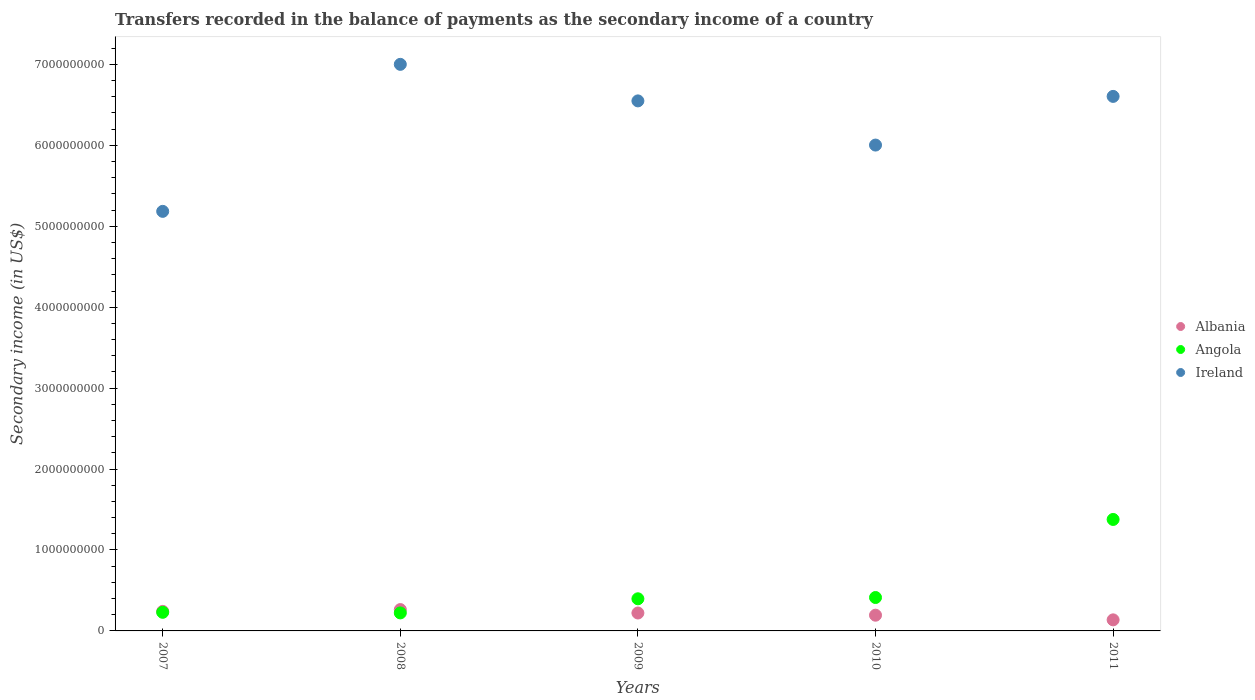Is the number of dotlines equal to the number of legend labels?
Provide a succinct answer. Yes. What is the secondary income of in Albania in 2007?
Your answer should be compact. 2.41e+08. Across all years, what is the maximum secondary income of in Angola?
Provide a succinct answer. 1.38e+09. Across all years, what is the minimum secondary income of in Albania?
Provide a succinct answer. 1.37e+08. In which year was the secondary income of in Angola maximum?
Offer a terse response. 2011. What is the total secondary income of in Angola in the graph?
Give a very brief answer. 2.64e+09. What is the difference between the secondary income of in Ireland in 2009 and that in 2010?
Make the answer very short. 5.46e+08. What is the difference between the secondary income of in Albania in 2009 and the secondary income of in Ireland in 2007?
Ensure brevity in your answer.  -4.96e+09. What is the average secondary income of in Albania per year?
Provide a short and direct response. 2.12e+08. In the year 2007, what is the difference between the secondary income of in Ireland and secondary income of in Albania?
Your answer should be very brief. 4.94e+09. In how many years, is the secondary income of in Angola greater than 3200000000 US$?
Provide a succinct answer. 0. What is the ratio of the secondary income of in Albania in 2008 to that in 2010?
Your answer should be compact. 1.36. What is the difference between the highest and the second highest secondary income of in Ireland?
Ensure brevity in your answer.  3.96e+08. What is the difference between the highest and the lowest secondary income of in Angola?
Your answer should be very brief. 1.15e+09. In how many years, is the secondary income of in Angola greater than the average secondary income of in Angola taken over all years?
Offer a very short reply. 1. Is the sum of the secondary income of in Albania in 2007 and 2010 greater than the maximum secondary income of in Angola across all years?
Offer a very short reply. No. Is it the case that in every year, the sum of the secondary income of in Albania and secondary income of in Ireland  is greater than the secondary income of in Angola?
Make the answer very short. Yes. Does the secondary income of in Angola monotonically increase over the years?
Make the answer very short. No. Is the secondary income of in Ireland strictly less than the secondary income of in Angola over the years?
Your answer should be compact. No. How many years are there in the graph?
Provide a succinct answer. 5. What is the difference between two consecutive major ticks on the Y-axis?
Your answer should be very brief. 1.00e+09. Are the values on the major ticks of Y-axis written in scientific E-notation?
Offer a very short reply. No. Does the graph contain grids?
Your response must be concise. No. What is the title of the graph?
Give a very brief answer. Transfers recorded in the balance of payments as the secondary income of a country. Does "Netherlands" appear as one of the legend labels in the graph?
Your answer should be compact. No. What is the label or title of the Y-axis?
Give a very brief answer. Secondary income (in US$). What is the Secondary income (in US$) of Albania in 2007?
Give a very brief answer. 2.41e+08. What is the Secondary income (in US$) of Angola in 2007?
Provide a short and direct response. 2.30e+08. What is the Secondary income (in US$) in Ireland in 2007?
Your response must be concise. 5.18e+09. What is the Secondary income (in US$) in Albania in 2008?
Your answer should be compact. 2.64e+08. What is the Secondary income (in US$) of Angola in 2008?
Your answer should be compact. 2.22e+08. What is the Secondary income (in US$) in Ireland in 2008?
Your answer should be very brief. 7.00e+09. What is the Secondary income (in US$) in Albania in 2009?
Provide a short and direct response. 2.21e+08. What is the Secondary income (in US$) of Angola in 2009?
Offer a terse response. 3.97e+08. What is the Secondary income (in US$) in Ireland in 2009?
Your response must be concise. 6.55e+09. What is the Secondary income (in US$) of Albania in 2010?
Give a very brief answer. 1.94e+08. What is the Secondary income (in US$) of Angola in 2010?
Provide a succinct answer. 4.13e+08. What is the Secondary income (in US$) in Ireland in 2010?
Provide a short and direct response. 6.00e+09. What is the Secondary income (in US$) of Albania in 2011?
Provide a short and direct response. 1.37e+08. What is the Secondary income (in US$) of Angola in 2011?
Give a very brief answer. 1.38e+09. What is the Secondary income (in US$) in Ireland in 2011?
Make the answer very short. 6.61e+09. Across all years, what is the maximum Secondary income (in US$) of Albania?
Your response must be concise. 2.64e+08. Across all years, what is the maximum Secondary income (in US$) of Angola?
Your answer should be compact. 1.38e+09. Across all years, what is the maximum Secondary income (in US$) of Ireland?
Give a very brief answer. 7.00e+09. Across all years, what is the minimum Secondary income (in US$) of Albania?
Offer a very short reply. 1.37e+08. Across all years, what is the minimum Secondary income (in US$) in Angola?
Your response must be concise. 2.22e+08. Across all years, what is the minimum Secondary income (in US$) of Ireland?
Offer a terse response. 5.18e+09. What is the total Secondary income (in US$) in Albania in the graph?
Provide a short and direct response. 1.06e+09. What is the total Secondary income (in US$) in Angola in the graph?
Ensure brevity in your answer.  2.64e+09. What is the total Secondary income (in US$) in Ireland in the graph?
Give a very brief answer. 3.13e+1. What is the difference between the Secondary income (in US$) of Albania in 2007 and that in 2008?
Provide a short and direct response. -2.24e+07. What is the difference between the Secondary income (in US$) of Angola in 2007 and that in 2008?
Your response must be concise. 7.45e+06. What is the difference between the Secondary income (in US$) of Ireland in 2007 and that in 2008?
Offer a terse response. -1.82e+09. What is the difference between the Secondary income (in US$) in Albania in 2007 and that in 2009?
Keep it short and to the point. 2.00e+07. What is the difference between the Secondary income (in US$) of Angola in 2007 and that in 2009?
Offer a terse response. -1.67e+08. What is the difference between the Secondary income (in US$) of Ireland in 2007 and that in 2009?
Keep it short and to the point. -1.37e+09. What is the difference between the Secondary income (in US$) of Albania in 2007 and that in 2010?
Make the answer very short. 4.71e+07. What is the difference between the Secondary income (in US$) of Angola in 2007 and that in 2010?
Make the answer very short. -1.83e+08. What is the difference between the Secondary income (in US$) of Ireland in 2007 and that in 2010?
Give a very brief answer. -8.19e+08. What is the difference between the Secondary income (in US$) in Albania in 2007 and that in 2011?
Ensure brevity in your answer.  1.05e+08. What is the difference between the Secondary income (in US$) in Angola in 2007 and that in 2011?
Make the answer very short. -1.15e+09. What is the difference between the Secondary income (in US$) of Ireland in 2007 and that in 2011?
Give a very brief answer. -1.42e+09. What is the difference between the Secondary income (in US$) in Albania in 2008 and that in 2009?
Make the answer very short. 4.23e+07. What is the difference between the Secondary income (in US$) of Angola in 2008 and that in 2009?
Offer a terse response. -1.75e+08. What is the difference between the Secondary income (in US$) in Ireland in 2008 and that in 2009?
Offer a terse response. 4.52e+08. What is the difference between the Secondary income (in US$) in Albania in 2008 and that in 2010?
Make the answer very short. 6.94e+07. What is the difference between the Secondary income (in US$) in Angola in 2008 and that in 2010?
Ensure brevity in your answer.  -1.90e+08. What is the difference between the Secondary income (in US$) of Ireland in 2008 and that in 2010?
Your answer should be compact. 9.97e+08. What is the difference between the Secondary income (in US$) in Albania in 2008 and that in 2011?
Make the answer very short. 1.27e+08. What is the difference between the Secondary income (in US$) of Angola in 2008 and that in 2011?
Your answer should be very brief. -1.15e+09. What is the difference between the Secondary income (in US$) in Ireland in 2008 and that in 2011?
Your answer should be compact. 3.96e+08. What is the difference between the Secondary income (in US$) of Albania in 2009 and that in 2010?
Your answer should be compact. 2.71e+07. What is the difference between the Secondary income (in US$) of Angola in 2009 and that in 2010?
Provide a short and direct response. -1.57e+07. What is the difference between the Secondary income (in US$) of Ireland in 2009 and that in 2010?
Ensure brevity in your answer.  5.46e+08. What is the difference between the Secondary income (in US$) in Albania in 2009 and that in 2011?
Provide a succinct answer. 8.47e+07. What is the difference between the Secondary income (in US$) of Angola in 2009 and that in 2011?
Give a very brief answer. -9.80e+08. What is the difference between the Secondary income (in US$) of Ireland in 2009 and that in 2011?
Your answer should be compact. -5.56e+07. What is the difference between the Secondary income (in US$) in Albania in 2010 and that in 2011?
Offer a very short reply. 5.76e+07. What is the difference between the Secondary income (in US$) in Angola in 2010 and that in 2011?
Offer a very short reply. -9.65e+08. What is the difference between the Secondary income (in US$) in Ireland in 2010 and that in 2011?
Make the answer very short. -6.02e+08. What is the difference between the Secondary income (in US$) of Albania in 2007 and the Secondary income (in US$) of Angola in 2008?
Provide a succinct answer. 1.89e+07. What is the difference between the Secondary income (in US$) of Albania in 2007 and the Secondary income (in US$) of Ireland in 2008?
Offer a terse response. -6.76e+09. What is the difference between the Secondary income (in US$) in Angola in 2007 and the Secondary income (in US$) in Ireland in 2008?
Offer a terse response. -6.77e+09. What is the difference between the Secondary income (in US$) of Albania in 2007 and the Secondary income (in US$) of Angola in 2009?
Your answer should be very brief. -1.56e+08. What is the difference between the Secondary income (in US$) of Albania in 2007 and the Secondary income (in US$) of Ireland in 2009?
Make the answer very short. -6.31e+09. What is the difference between the Secondary income (in US$) of Angola in 2007 and the Secondary income (in US$) of Ireland in 2009?
Offer a terse response. -6.32e+09. What is the difference between the Secondary income (in US$) in Albania in 2007 and the Secondary income (in US$) in Angola in 2010?
Keep it short and to the point. -1.71e+08. What is the difference between the Secondary income (in US$) of Albania in 2007 and the Secondary income (in US$) of Ireland in 2010?
Offer a terse response. -5.76e+09. What is the difference between the Secondary income (in US$) in Angola in 2007 and the Secondary income (in US$) in Ireland in 2010?
Your answer should be compact. -5.77e+09. What is the difference between the Secondary income (in US$) of Albania in 2007 and the Secondary income (in US$) of Angola in 2011?
Offer a terse response. -1.14e+09. What is the difference between the Secondary income (in US$) in Albania in 2007 and the Secondary income (in US$) in Ireland in 2011?
Make the answer very short. -6.36e+09. What is the difference between the Secondary income (in US$) in Angola in 2007 and the Secondary income (in US$) in Ireland in 2011?
Your answer should be very brief. -6.38e+09. What is the difference between the Secondary income (in US$) in Albania in 2008 and the Secondary income (in US$) in Angola in 2009?
Provide a succinct answer. -1.33e+08. What is the difference between the Secondary income (in US$) of Albania in 2008 and the Secondary income (in US$) of Ireland in 2009?
Offer a very short reply. -6.29e+09. What is the difference between the Secondary income (in US$) of Angola in 2008 and the Secondary income (in US$) of Ireland in 2009?
Your response must be concise. -6.33e+09. What is the difference between the Secondary income (in US$) of Albania in 2008 and the Secondary income (in US$) of Angola in 2010?
Your response must be concise. -1.49e+08. What is the difference between the Secondary income (in US$) of Albania in 2008 and the Secondary income (in US$) of Ireland in 2010?
Your answer should be compact. -5.74e+09. What is the difference between the Secondary income (in US$) in Angola in 2008 and the Secondary income (in US$) in Ireland in 2010?
Your answer should be very brief. -5.78e+09. What is the difference between the Secondary income (in US$) of Albania in 2008 and the Secondary income (in US$) of Angola in 2011?
Your response must be concise. -1.11e+09. What is the difference between the Secondary income (in US$) of Albania in 2008 and the Secondary income (in US$) of Ireland in 2011?
Ensure brevity in your answer.  -6.34e+09. What is the difference between the Secondary income (in US$) in Angola in 2008 and the Secondary income (in US$) in Ireland in 2011?
Give a very brief answer. -6.38e+09. What is the difference between the Secondary income (in US$) of Albania in 2009 and the Secondary income (in US$) of Angola in 2010?
Make the answer very short. -1.91e+08. What is the difference between the Secondary income (in US$) in Albania in 2009 and the Secondary income (in US$) in Ireland in 2010?
Ensure brevity in your answer.  -5.78e+09. What is the difference between the Secondary income (in US$) of Angola in 2009 and the Secondary income (in US$) of Ireland in 2010?
Your answer should be compact. -5.61e+09. What is the difference between the Secondary income (in US$) in Albania in 2009 and the Secondary income (in US$) in Angola in 2011?
Give a very brief answer. -1.16e+09. What is the difference between the Secondary income (in US$) in Albania in 2009 and the Secondary income (in US$) in Ireland in 2011?
Give a very brief answer. -6.38e+09. What is the difference between the Secondary income (in US$) of Angola in 2009 and the Secondary income (in US$) of Ireland in 2011?
Offer a terse response. -6.21e+09. What is the difference between the Secondary income (in US$) in Albania in 2010 and the Secondary income (in US$) in Angola in 2011?
Provide a short and direct response. -1.18e+09. What is the difference between the Secondary income (in US$) of Albania in 2010 and the Secondary income (in US$) of Ireland in 2011?
Make the answer very short. -6.41e+09. What is the difference between the Secondary income (in US$) of Angola in 2010 and the Secondary income (in US$) of Ireland in 2011?
Provide a succinct answer. -6.19e+09. What is the average Secondary income (in US$) in Albania per year?
Offer a terse response. 2.12e+08. What is the average Secondary income (in US$) of Angola per year?
Your answer should be compact. 5.28e+08. What is the average Secondary income (in US$) of Ireland per year?
Offer a very short reply. 6.27e+09. In the year 2007, what is the difference between the Secondary income (in US$) in Albania and Secondary income (in US$) in Angola?
Your answer should be very brief. 1.15e+07. In the year 2007, what is the difference between the Secondary income (in US$) of Albania and Secondary income (in US$) of Ireland?
Ensure brevity in your answer.  -4.94e+09. In the year 2007, what is the difference between the Secondary income (in US$) of Angola and Secondary income (in US$) of Ireland?
Ensure brevity in your answer.  -4.95e+09. In the year 2008, what is the difference between the Secondary income (in US$) of Albania and Secondary income (in US$) of Angola?
Offer a terse response. 4.13e+07. In the year 2008, what is the difference between the Secondary income (in US$) in Albania and Secondary income (in US$) in Ireland?
Make the answer very short. -6.74e+09. In the year 2008, what is the difference between the Secondary income (in US$) of Angola and Secondary income (in US$) of Ireland?
Your answer should be compact. -6.78e+09. In the year 2009, what is the difference between the Secondary income (in US$) of Albania and Secondary income (in US$) of Angola?
Offer a very short reply. -1.76e+08. In the year 2009, what is the difference between the Secondary income (in US$) of Albania and Secondary income (in US$) of Ireland?
Keep it short and to the point. -6.33e+09. In the year 2009, what is the difference between the Secondary income (in US$) in Angola and Secondary income (in US$) in Ireland?
Provide a succinct answer. -6.15e+09. In the year 2010, what is the difference between the Secondary income (in US$) of Albania and Secondary income (in US$) of Angola?
Your response must be concise. -2.18e+08. In the year 2010, what is the difference between the Secondary income (in US$) in Albania and Secondary income (in US$) in Ireland?
Your answer should be compact. -5.81e+09. In the year 2010, what is the difference between the Secondary income (in US$) of Angola and Secondary income (in US$) of Ireland?
Your answer should be compact. -5.59e+09. In the year 2011, what is the difference between the Secondary income (in US$) in Albania and Secondary income (in US$) in Angola?
Offer a very short reply. -1.24e+09. In the year 2011, what is the difference between the Secondary income (in US$) in Albania and Secondary income (in US$) in Ireland?
Your answer should be very brief. -6.47e+09. In the year 2011, what is the difference between the Secondary income (in US$) in Angola and Secondary income (in US$) in Ireland?
Offer a very short reply. -5.23e+09. What is the ratio of the Secondary income (in US$) in Albania in 2007 to that in 2008?
Give a very brief answer. 0.92. What is the ratio of the Secondary income (in US$) of Angola in 2007 to that in 2008?
Ensure brevity in your answer.  1.03. What is the ratio of the Secondary income (in US$) in Ireland in 2007 to that in 2008?
Offer a terse response. 0.74. What is the ratio of the Secondary income (in US$) in Albania in 2007 to that in 2009?
Offer a very short reply. 1.09. What is the ratio of the Secondary income (in US$) in Angola in 2007 to that in 2009?
Offer a very short reply. 0.58. What is the ratio of the Secondary income (in US$) in Ireland in 2007 to that in 2009?
Offer a terse response. 0.79. What is the ratio of the Secondary income (in US$) in Albania in 2007 to that in 2010?
Your answer should be compact. 1.24. What is the ratio of the Secondary income (in US$) of Angola in 2007 to that in 2010?
Provide a succinct answer. 0.56. What is the ratio of the Secondary income (in US$) in Ireland in 2007 to that in 2010?
Ensure brevity in your answer.  0.86. What is the ratio of the Secondary income (in US$) in Albania in 2007 to that in 2011?
Offer a terse response. 1.77. What is the ratio of the Secondary income (in US$) in Angola in 2007 to that in 2011?
Your answer should be compact. 0.17. What is the ratio of the Secondary income (in US$) in Ireland in 2007 to that in 2011?
Your answer should be very brief. 0.78. What is the ratio of the Secondary income (in US$) in Albania in 2008 to that in 2009?
Offer a very short reply. 1.19. What is the ratio of the Secondary income (in US$) in Angola in 2008 to that in 2009?
Your answer should be very brief. 0.56. What is the ratio of the Secondary income (in US$) in Ireland in 2008 to that in 2009?
Provide a succinct answer. 1.07. What is the ratio of the Secondary income (in US$) of Albania in 2008 to that in 2010?
Offer a terse response. 1.36. What is the ratio of the Secondary income (in US$) of Angola in 2008 to that in 2010?
Make the answer very short. 0.54. What is the ratio of the Secondary income (in US$) of Ireland in 2008 to that in 2010?
Offer a terse response. 1.17. What is the ratio of the Secondary income (in US$) of Albania in 2008 to that in 2011?
Provide a short and direct response. 1.93. What is the ratio of the Secondary income (in US$) of Angola in 2008 to that in 2011?
Give a very brief answer. 0.16. What is the ratio of the Secondary income (in US$) in Ireland in 2008 to that in 2011?
Offer a very short reply. 1.06. What is the ratio of the Secondary income (in US$) in Albania in 2009 to that in 2010?
Your response must be concise. 1.14. What is the ratio of the Secondary income (in US$) of Ireland in 2009 to that in 2010?
Your response must be concise. 1.09. What is the ratio of the Secondary income (in US$) in Albania in 2009 to that in 2011?
Provide a short and direct response. 1.62. What is the ratio of the Secondary income (in US$) of Angola in 2009 to that in 2011?
Provide a succinct answer. 0.29. What is the ratio of the Secondary income (in US$) of Albania in 2010 to that in 2011?
Your answer should be very brief. 1.42. What is the ratio of the Secondary income (in US$) of Angola in 2010 to that in 2011?
Your answer should be very brief. 0.3. What is the ratio of the Secondary income (in US$) in Ireland in 2010 to that in 2011?
Ensure brevity in your answer.  0.91. What is the difference between the highest and the second highest Secondary income (in US$) in Albania?
Keep it short and to the point. 2.24e+07. What is the difference between the highest and the second highest Secondary income (in US$) of Angola?
Provide a succinct answer. 9.65e+08. What is the difference between the highest and the second highest Secondary income (in US$) of Ireland?
Make the answer very short. 3.96e+08. What is the difference between the highest and the lowest Secondary income (in US$) of Albania?
Provide a succinct answer. 1.27e+08. What is the difference between the highest and the lowest Secondary income (in US$) in Angola?
Your response must be concise. 1.15e+09. What is the difference between the highest and the lowest Secondary income (in US$) in Ireland?
Provide a short and direct response. 1.82e+09. 